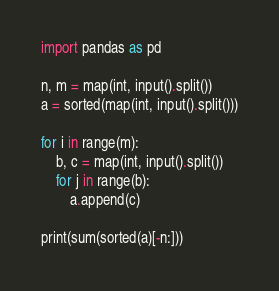<code> <loc_0><loc_0><loc_500><loc_500><_Python_>import pandas as pd

n, m = map(int, input().split())
a = sorted(map(int, input().split()))

for i in range(m):
    b, c = map(int, input().split())
    for j in range(b):
        a.append(c)

print(sum(sorted(a)[-n:]))</code> 